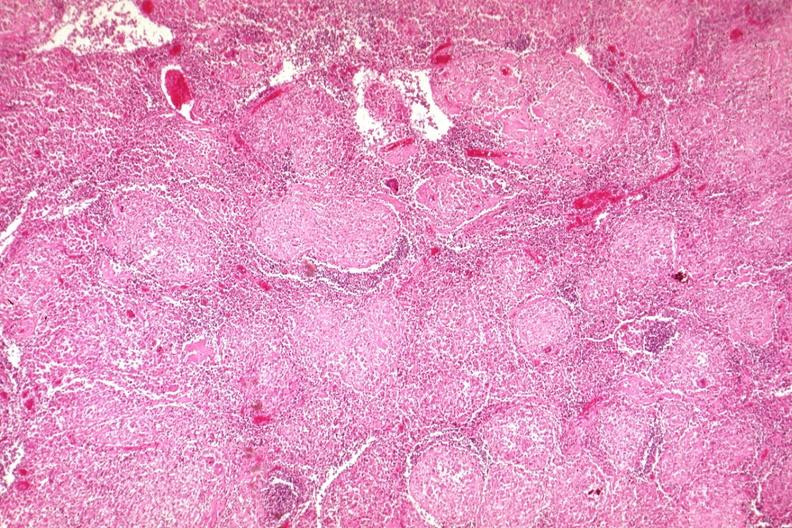s sarcoidosis present?
Answer the question using a single word or phrase. Yes 